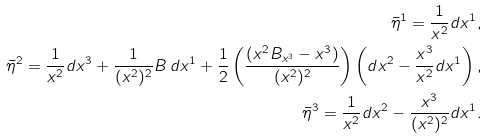<formula> <loc_0><loc_0><loc_500><loc_500>\bar { \eta } ^ { 1 } = \frac { 1 } { x ^ { 2 } } d x ^ { 1 } , \\ \bar { \eta } ^ { 2 } = \frac { 1 } { x ^ { 2 } } d x ^ { 3 } + \frac { 1 } { ( x ^ { 2 } ) ^ { 2 } } B \, d x ^ { 1 } + \frac { 1 } { 2 } \left ( \frac { ( x ^ { 2 } B _ { x ^ { 3 } } - x ^ { 3 } ) } { ( x ^ { 2 } ) ^ { 2 } } \right ) \left ( d x ^ { 2 } - \frac { x ^ { 3 } } { x ^ { 2 } } d x ^ { 1 } \right ) , \\ \bar { \eta } ^ { 3 } = \frac { 1 } { x ^ { 2 } } d x ^ { 2 } - \frac { x ^ { 3 } } { ( x ^ { 2 } ) ^ { 2 } } d x ^ { 1 } .</formula> 